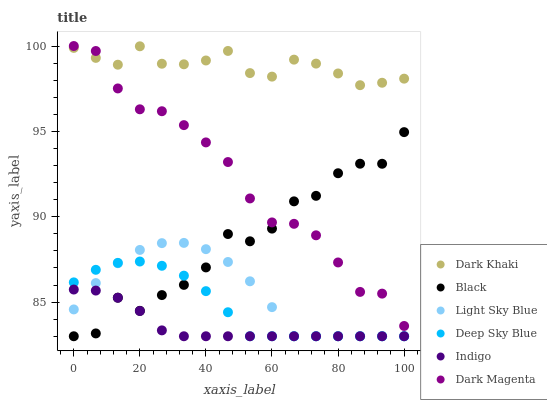Does Indigo have the minimum area under the curve?
Answer yes or no. Yes. Does Dark Khaki have the maximum area under the curve?
Answer yes or no. Yes. Does Dark Magenta have the minimum area under the curve?
Answer yes or no. No. Does Dark Magenta have the maximum area under the curve?
Answer yes or no. No. Is Indigo the smoothest?
Answer yes or no. Yes. Is Black the roughest?
Answer yes or no. Yes. Is Dark Magenta the smoothest?
Answer yes or no. No. Is Dark Magenta the roughest?
Answer yes or no. No. Does Indigo have the lowest value?
Answer yes or no. Yes. Does Dark Magenta have the lowest value?
Answer yes or no. No. Does Dark Magenta have the highest value?
Answer yes or no. Yes. Does Dark Khaki have the highest value?
Answer yes or no. No. Is Light Sky Blue less than Dark Magenta?
Answer yes or no. Yes. Is Dark Khaki greater than Light Sky Blue?
Answer yes or no. Yes. Does Deep Sky Blue intersect Indigo?
Answer yes or no. Yes. Is Deep Sky Blue less than Indigo?
Answer yes or no. No. Is Deep Sky Blue greater than Indigo?
Answer yes or no. No. Does Light Sky Blue intersect Dark Magenta?
Answer yes or no. No. 